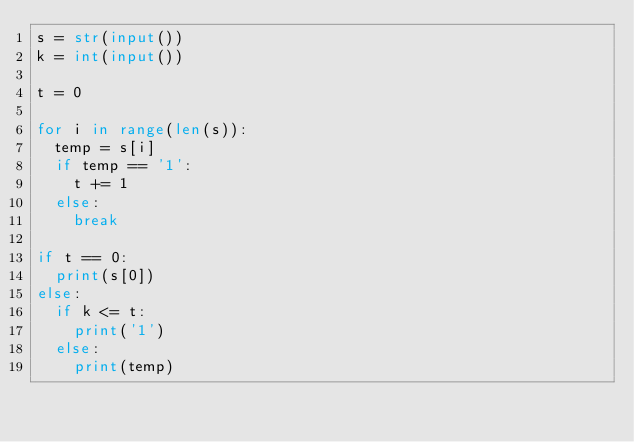Convert code to text. <code><loc_0><loc_0><loc_500><loc_500><_Python_>s = str(input())
k = int(input())

t = 0
  
for i in range(len(s)):
  temp = s[i]
  if temp == '1':
    t += 1
  else:
    break

if t == 0:
  print(s[0])
else:
  if k <= t:
    print('1')
  else:
    print(temp)
    
 </code> 